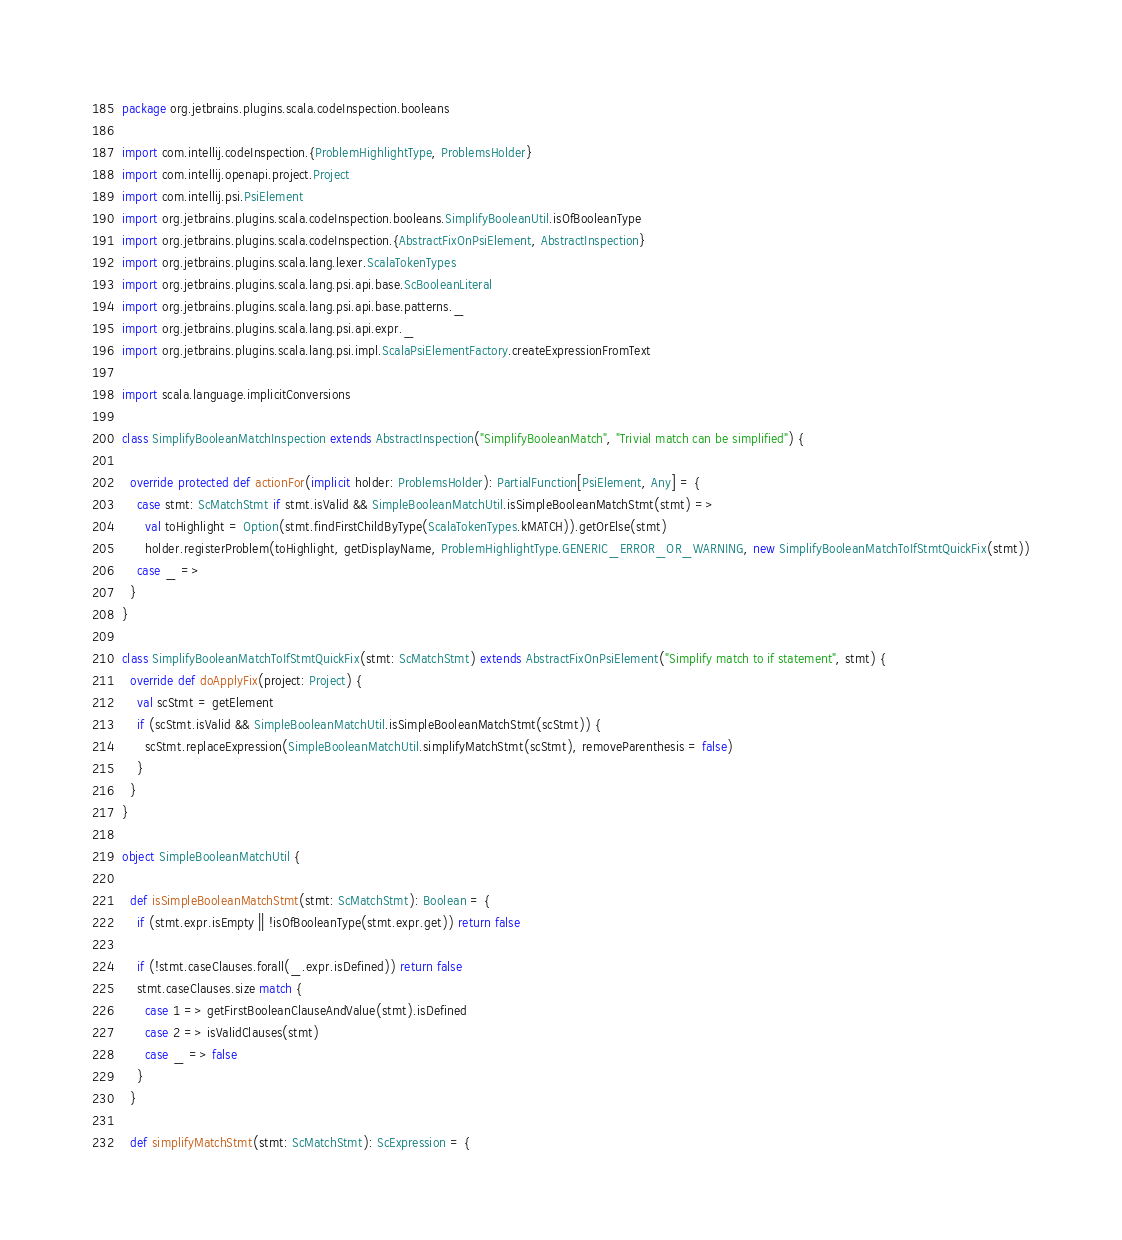<code> <loc_0><loc_0><loc_500><loc_500><_Scala_>package org.jetbrains.plugins.scala.codeInspection.booleans

import com.intellij.codeInspection.{ProblemHighlightType, ProblemsHolder}
import com.intellij.openapi.project.Project
import com.intellij.psi.PsiElement
import org.jetbrains.plugins.scala.codeInspection.booleans.SimplifyBooleanUtil.isOfBooleanType
import org.jetbrains.plugins.scala.codeInspection.{AbstractFixOnPsiElement, AbstractInspection}
import org.jetbrains.plugins.scala.lang.lexer.ScalaTokenTypes
import org.jetbrains.plugins.scala.lang.psi.api.base.ScBooleanLiteral
import org.jetbrains.plugins.scala.lang.psi.api.base.patterns._
import org.jetbrains.plugins.scala.lang.psi.api.expr._
import org.jetbrains.plugins.scala.lang.psi.impl.ScalaPsiElementFactory.createExpressionFromText

import scala.language.implicitConversions

class SimplifyBooleanMatchInspection extends AbstractInspection("SimplifyBooleanMatch", "Trivial match can be simplified") {

  override protected def actionFor(implicit holder: ProblemsHolder): PartialFunction[PsiElement, Any] = {
    case stmt: ScMatchStmt if stmt.isValid && SimpleBooleanMatchUtil.isSimpleBooleanMatchStmt(stmt) =>
      val toHighlight = Option(stmt.findFirstChildByType(ScalaTokenTypes.kMATCH)).getOrElse(stmt)
      holder.registerProblem(toHighlight, getDisplayName, ProblemHighlightType.GENERIC_ERROR_OR_WARNING, new SimplifyBooleanMatchToIfStmtQuickFix(stmt))
    case _ =>
  }
}

class SimplifyBooleanMatchToIfStmtQuickFix(stmt: ScMatchStmt) extends AbstractFixOnPsiElement("Simplify match to if statement", stmt) {
  override def doApplyFix(project: Project) {
    val scStmt = getElement
    if (scStmt.isValid && SimpleBooleanMatchUtil.isSimpleBooleanMatchStmt(scStmt)) {
      scStmt.replaceExpression(SimpleBooleanMatchUtil.simplifyMatchStmt(scStmt), removeParenthesis = false)
    }
  }
}

object SimpleBooleanMatchUtil {

  def isSimpleBooleanMatchStmt(stmt: ScMatchStmt): Boolean = {
    if (stmt.expr.isEmpty || !isOfBooleanType(stmt.expr.get)) return false

    if (!stmt.caseClauses.forall(_.expr.isDefined)) return false
    stmt.caseClauses.size match {
      case 1 => getFirstBooleanClauseAndValue(stmt).isDefined
      case 2 => isValidClauses(stmt)
      case _ => false
    }
  }

  def simplifyMatchStmt(stmt: ScMatchStmt): ScExpression = {</code> 